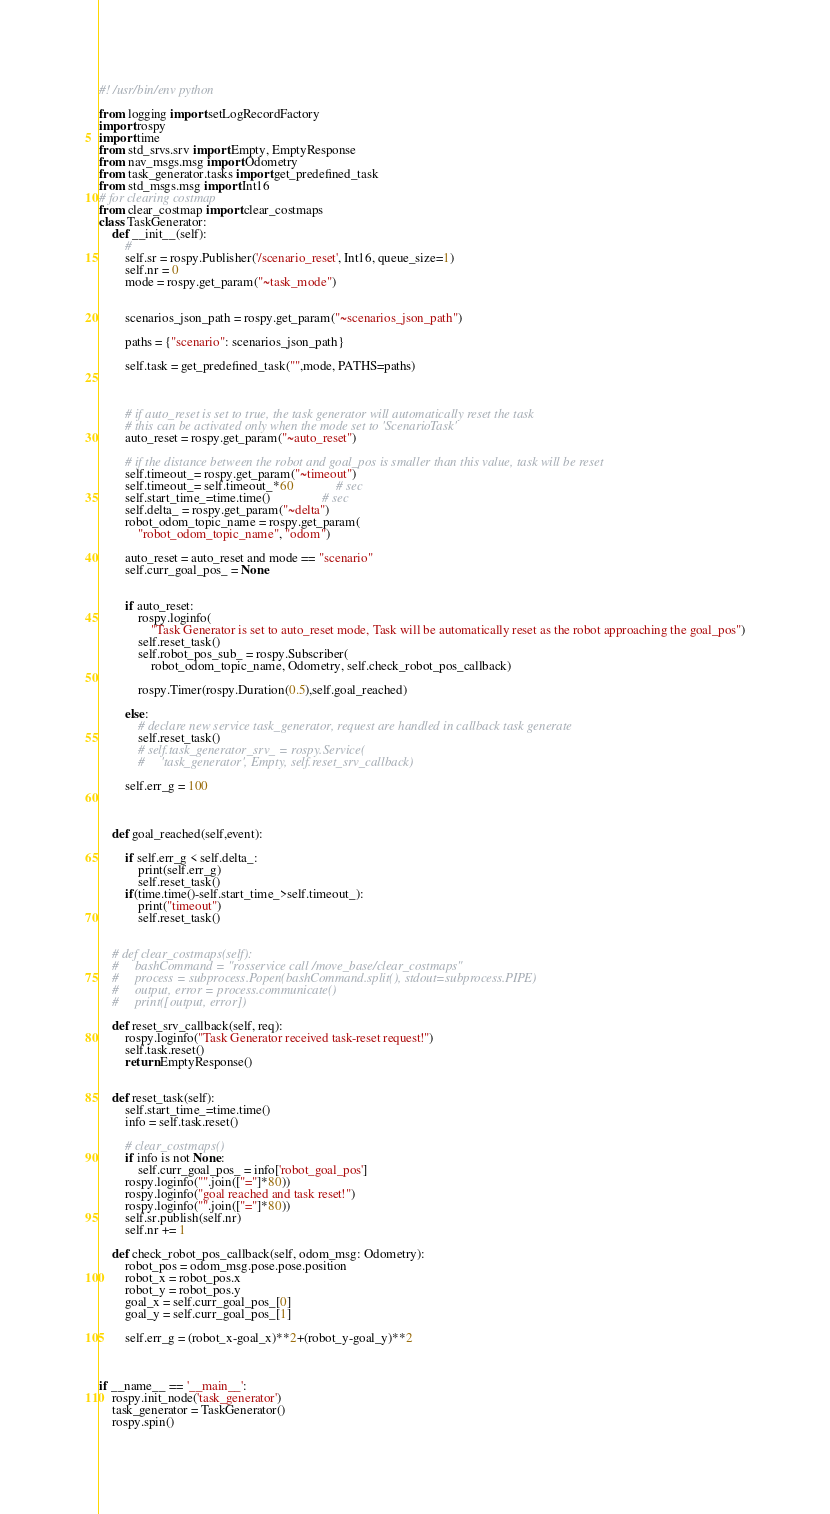<code> <loc_0><loc_0><loc_500><loc_500><_Python_>#! /usr/bin/env python

from logging import setLogRecordFactory
import rospy
import time
from std_srvs.srv import Empty, EmptyResponse
from nav_msgs.msg import Odometry
from task_generator.tasks import get_predefined_task
from std_msgs.msg import Int16
# for clearing costmap
from clear_costmap import clear_costmaps
class TaskGenerator:
    def __init__(self):
        #
        self.sr = rospy.Publisher('/scenario_reset', Int16, queue_size=1)
        self.nr = 0
        mode = rospy.get_param("~task_mode")
        
        
        scenarios_json_path = rospy.get_param("~scenarios_json_path")
       
        paths = {"scenario": scenarios_json_path}
  
        self.task = get_predefined_task("",mode, PATHS=paths)
       


        # if auto_reset is set to true, the task generator will automatically reset the task
        # this can be activated only when the mode set to 'ScenarioTask'
        auto_reset = rospy.get_param("~auto_reset")

        # if the distance between the robot and goal_pos is smaller than this value, task will be reset
        self.timeout_= rospy.get_param("~timeout")
        self.timeout_= self.timeout_*60             # sec
        self.start_time_=time.time()                # sec
        self.delta_ = rospy.get_param("~delta")
        robot_odom_topic_name = rospy.get_param(
            "robot_odom_topic_name", "odom")
        
        auto_reset = auto_reset and mode == "scenario"
        self.curr_goal_pos_ = None
        
        
        if auto_reset:
            rospy.loginfo(
                "Task Generator is set to auto_reset mode, Task will be automatically reset as the robot approaching the goal_pos")
            self.reset_task()
            self.robot_pos_sub_ = rospy.Subscriber(
                robot_odom_topic_name, Odometry, self.check_robot_pos_callback)

            rospy.Timer(rospy.Duration(0.5),self.goal_reached)
            
        else:
            # declare new service task_generator, request are handled in callback task generate
            self.reset_task()
            # self.task_generator_srv_ = rospy.Service(
            #     'task_generator', Empty, self.reset_srv_callback)
                
        self.err_g = 100
        


    def goal_reached(self,event):

        if self.err_g < self.delta_:
            print(self.err_g)
            self.reset_task()
        if(time.time()-self.start_time_>self.timeout_):
            print("timeout")
            self.reset_task()


    # def clear_costmaps(self):
    #     bashCommand = "rosservice call /move_base/clear_costmaps"
    #     process = subprocess.Popen(bashCommand.split(), stdout=subprocess.PIPE)
    #     output, error = process.communicate()
    #     print([output, error])

    def reset_srv_callback(self, req):
        rospy.loginfo("Task Generator received task-reset request!")
        self.task.reset()
        return EmptyResponse()


    def reset_task(self):
        self.start_time_=time.time()
        info = self.task.reset()
        
        # clear_costmaps()
        if info is not None:
            self.curr_goal_pos_ = info['robot_goal_pos']
        rospy.loginfo("".join(["="]*80))
        rospy.loginfo("goal reached and task reset!")
        rospy.loginfo("".join(["="]*80))
        self.sr.publish(self.nr)
        self.nr += 1

    def check_robot_pos_callback(self, odom_msg: Odometry):
        robot_pos = odom_msg.pose.pose.position
        robot_x = robot_pos.x
        robot_y = robot_pos.y
        goal_x = self.curr_goal_pos_[0]
        goal_y = self.curr_goal_pos_[1]

        self.err_g = (robot_x-goal_x)**2+(robot_y-goal_y)**2
           


if __name__ == '__main__':
    rospy.init_node('task_generator')
    task_generator = TaskGenerator()
    rospy.spin()</code> 